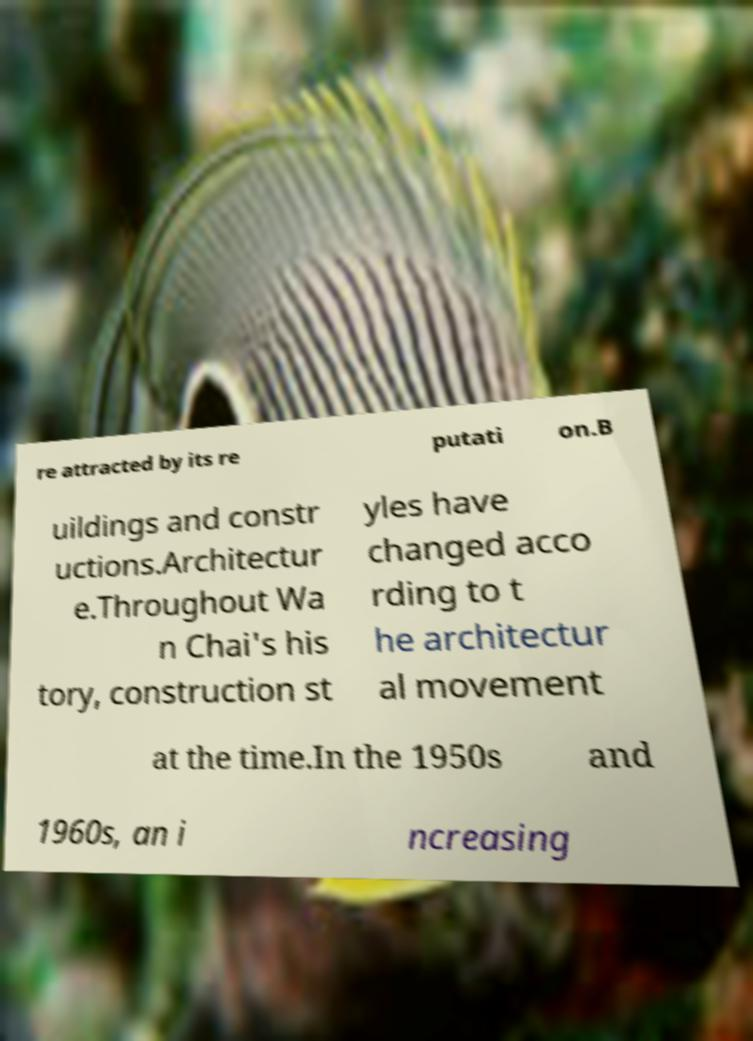There's text embedded in this image that I need extracted. Can you transcribe it verbatim? re attracted by its re putati on.B uildings and constr uctions.Architectur e.Throughout Wa n Chai's his tory, construction st yles have changed acco rding to t he architectur al movement at the time.In the 1950s and 1960s, an i ncreasing 